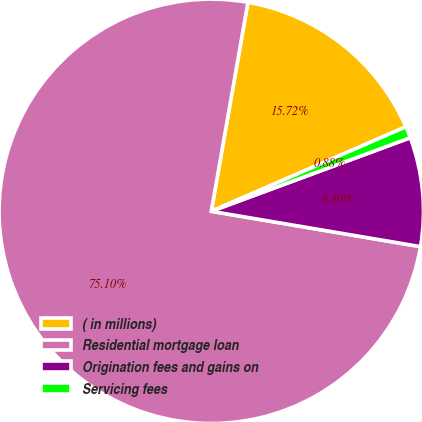Convert chart. <chart><loc_0><loc_0><loc_500><loc_500><pie_chart><fcel>( in millions)<fcel>Residential mortgage loan<fcel>Origination fees and gains on<fcel>Servicing fees<nl><fcel>15.72%<fcel>75.1%<fcel>8.3%<fcel>0.88%<nl></chart> 